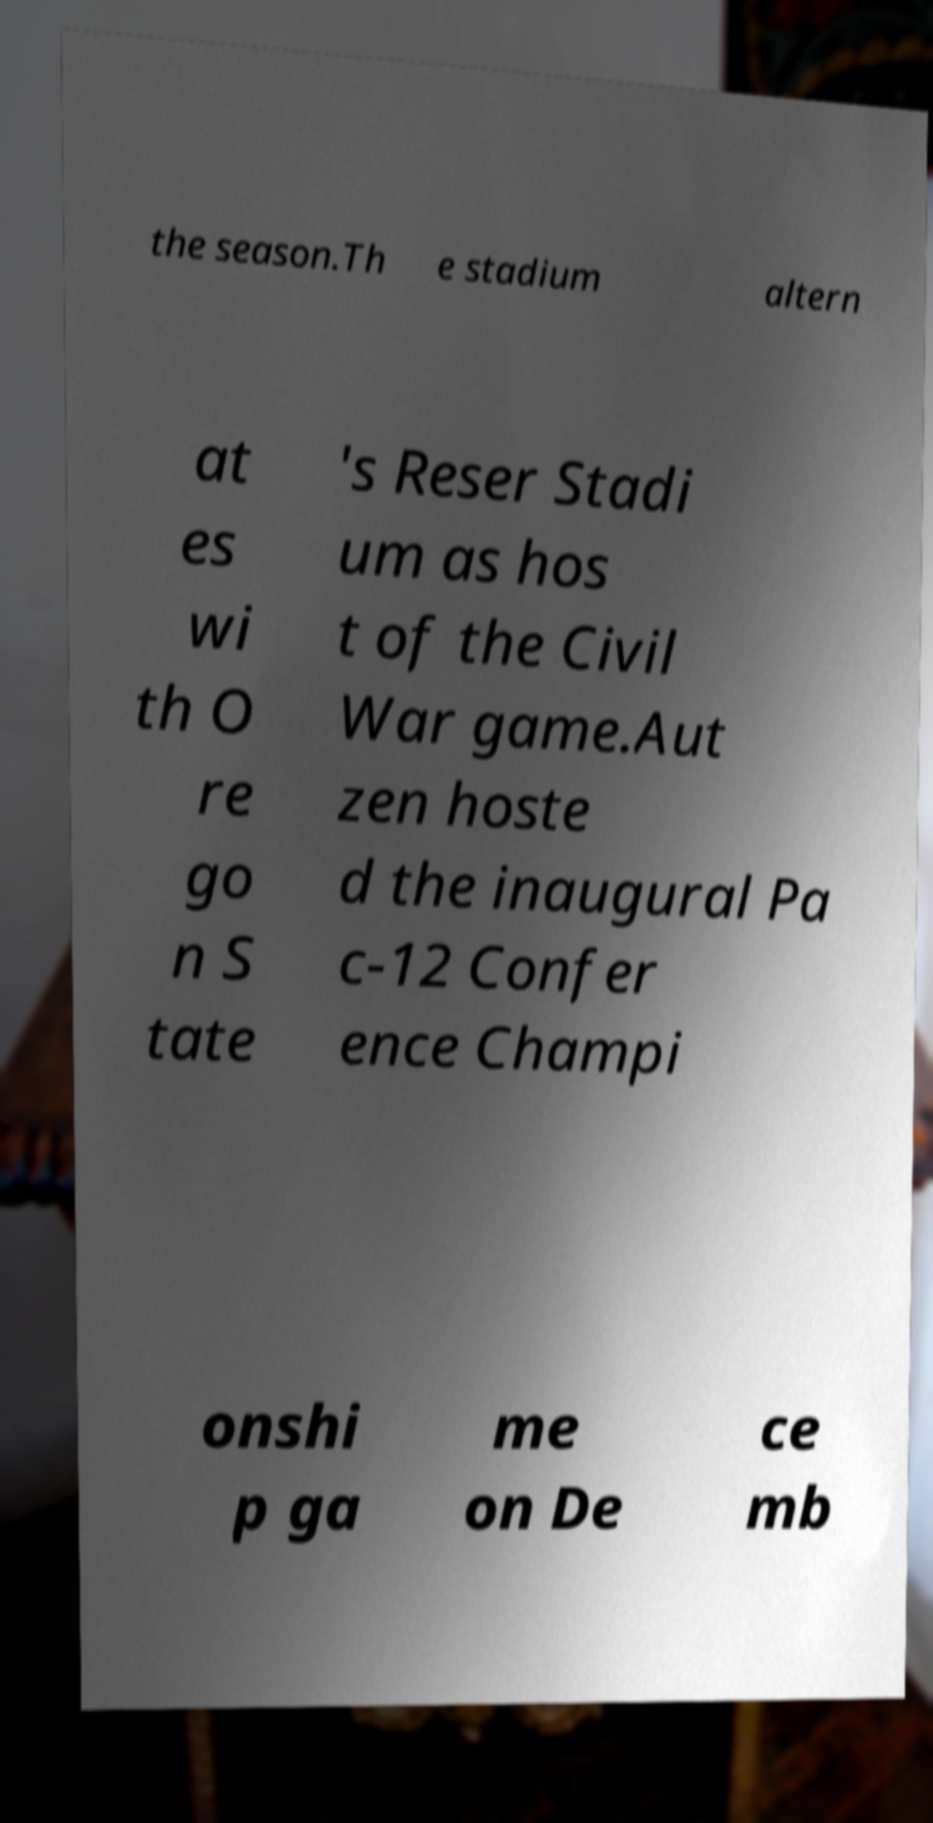Please read and relay the text visible in this image. What does it say? the season.Th e stadium altern at es wi th O re go n S tate 's Reser Stadi um as hos t of the Civil War game.Aut zen hoste d the inaugural Pa c-12 Confer ence Champi onshi p ga me on De ce mb 